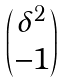Convert formula to latex. <formula><loc_0><loc_0><loc_500><loc_500>\begin{pmatrix} \delta ^ { 2 } \\ - 1 \end{pmatrix}</formula> 